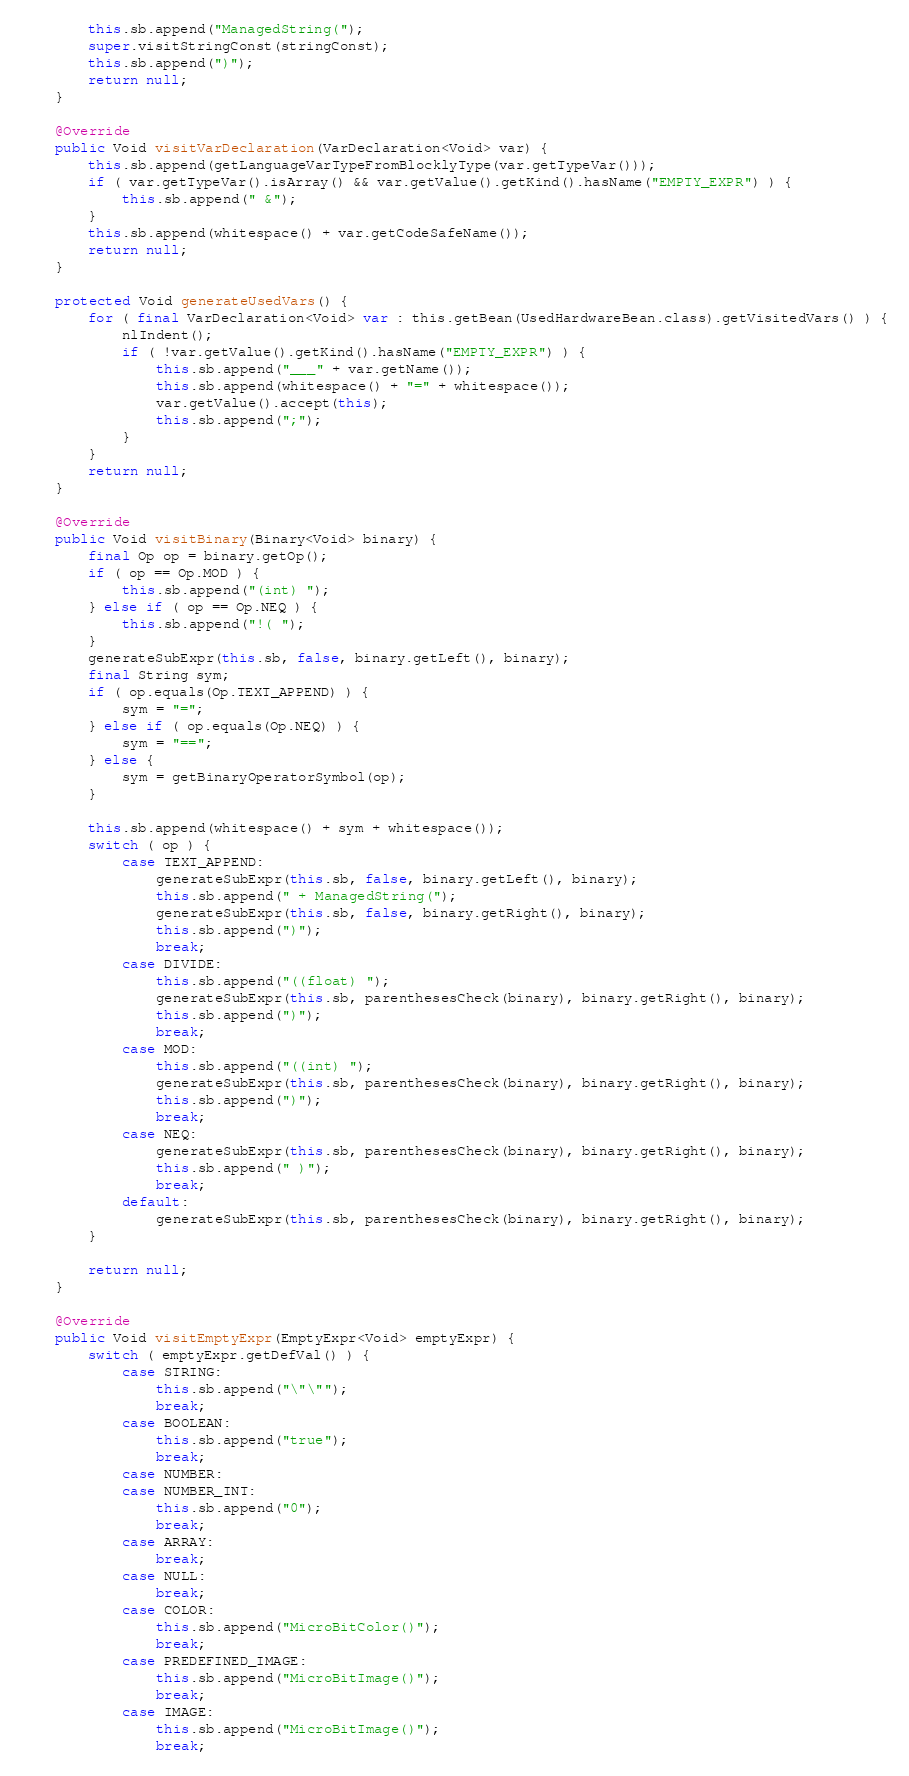<code> <loc_0><loc_0><loc_500><loc_500><_Java_>        this.sb.append("ManagedString(");
        super.visitStringConst(stringConst);
        this.sb.append(")");
        return null;
    }

    @Override
    public Void visitVarDeclaration(VarDeclaration<Void> var) {
        this.sb.append(getLanguageVarTypeFromBlocklyType(var.getTypeVar()));
        if ( var.getTypeVar().isArray() && var.getValue().getKind().hasName("EMPTY_EXPR") ) {
            this.sb.append(" &");
        }
        this.sb.append(whitespace() + var.getCodeSafeName());
        return null;
    }

    protected Void generateUsedVars() {
        for ( final VarDeclaration<Void> var : this.getBean(UsedHardwareBean.class).getVisitedVars() ) {
            nlIndent();
            if ( !var.getValue().getKind().hasName("EMPTY_EXPR") ) {
                this.sb.append("___" + var.getName());
                this.sb.append(whitespace() + "=" + whitespace());
                var.getValue().accept(this);
                this.sb.append(";");
            }
        }
        return null;
    }

    @Override
    public Void visitBinary(Binary<Void> binary) {
        final Op op = binary.getOp();
        if ( op == Op.MOD ) {
            this.sb.append("(int) ");
        } else if ( op == Op.NEQ ) {
            this.sb.append("!( ");
        }
        generateSubExpr(this.sb, false, binary.getLeft(), binary);
        final String sym;
        if ( op.equals(Op.TEXT_APPEND) ) {
            sym = "=";
        } else if ( op.equals(Op.NEQ) ) {
            sym = "==";
        } else {
            sym = getBinaryOperatorSymbol(op);
        }

        this.sb.append(whitespace() + sym + whitespace());
        switch ( op ) {
            case TEXT_APPEND:
                generateSubExpr(this.sb, false, binary.getLeft(), binary);
                this.sb.append(" + ManagedString(");
                generateSubExpr(this.sb, false, binary.getRight(), binary);
                this.sb.append(")");
                break;
            case DIVIDE:
                this.sb.append("((float) ");
                generateSubExpr(this.sb, parenthesesCheck(binary), binary.getRight(), binary);
                this.sb.append(")");
                break;
            case MOD:
                this.sb.append("((int) ");
                generateSubExpr(this.sb, parenthesesCheck(binary), binary.getRight(), binary);
                this.sb.append(")");
                break;
            case NEQ:
                generateSubExpr(this.sb, parenthesesCheck(binary), binary.getRight(), binary);
                this.sb.append(" )");
                break;
            default:
                generateSubExpr(this.sb, parenthesesCheck(binary), binary.getRight(), binary);
        }

        return null;
    }

    @Override
    public Void visitEmptyExpr(EmptyExpr<Void> emptyExpr) {
        switch ( emptyExpr.getDefVal() ) {
            case STRING:
                this.sb.append("\"\"");
                break;
            case BOOLEAN:
                this.sb.append("true");
                break;
            case NUMBER:
            case NUMBER_INT:
                this.sb.append("0");
                break;
            case ARRAY:
                break;
            case NULL:
                break;
            case COLOR:
                this.sb.append("MicroBitColor()");
                break;
            case PREDEFINED_IMAGE:
                this.sb.append("MicroBitImage()");
                break;
            case IMAGE:
                this.sb.append("MicroBitImage()");
                break;</code> 